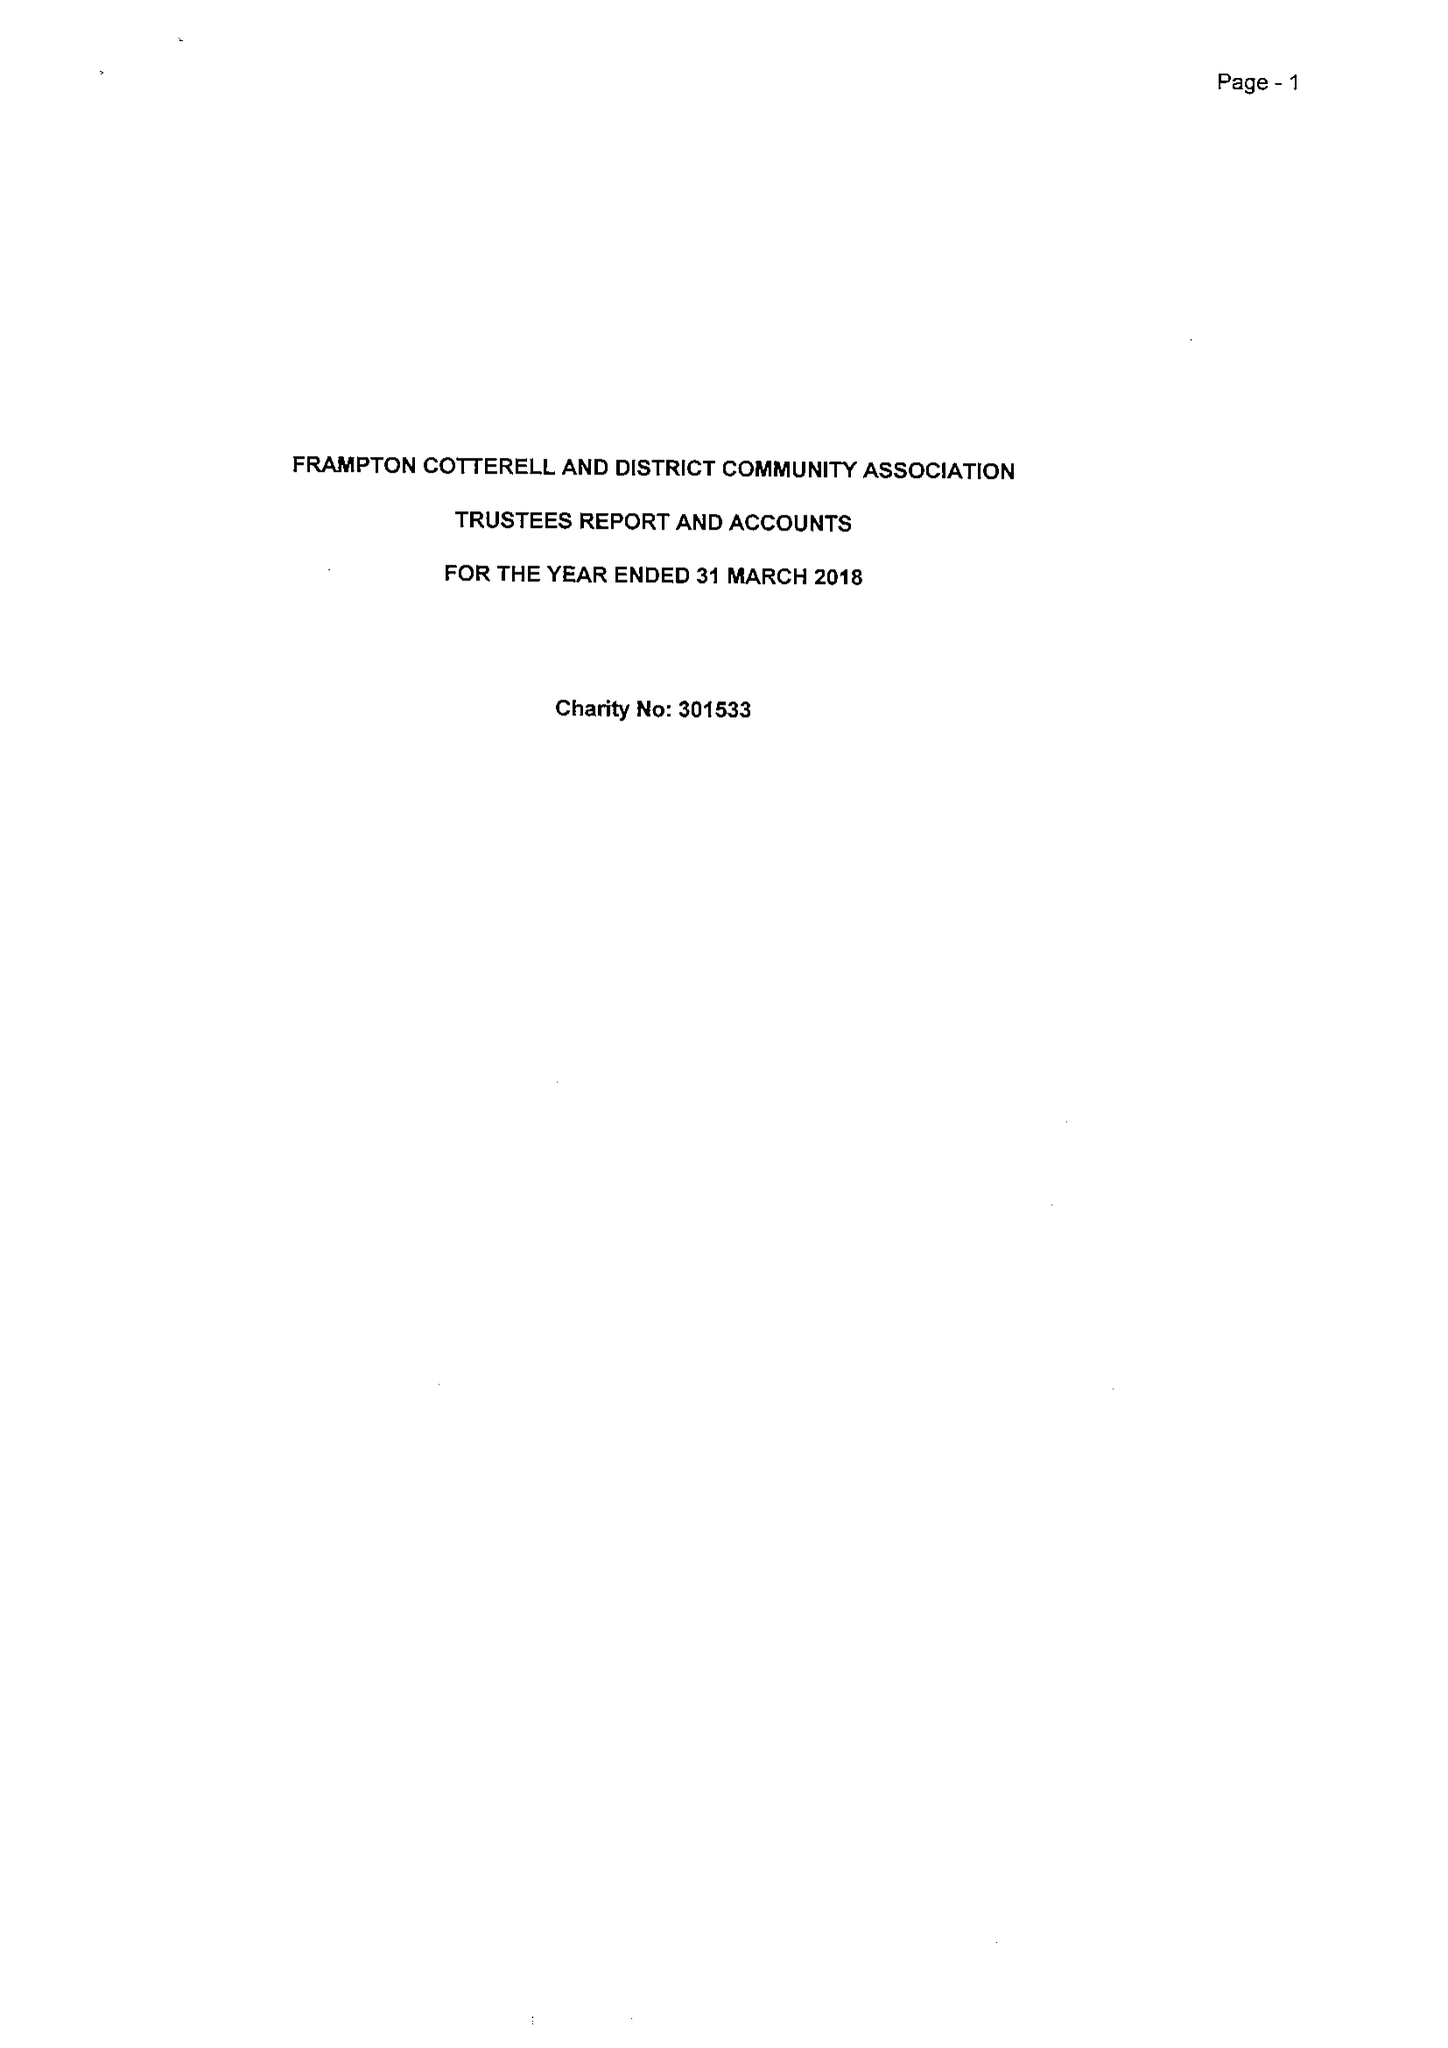What is the value for the spending_annually_in_british_pounds?
Answer the question using a single word or phrase. 16362.00 